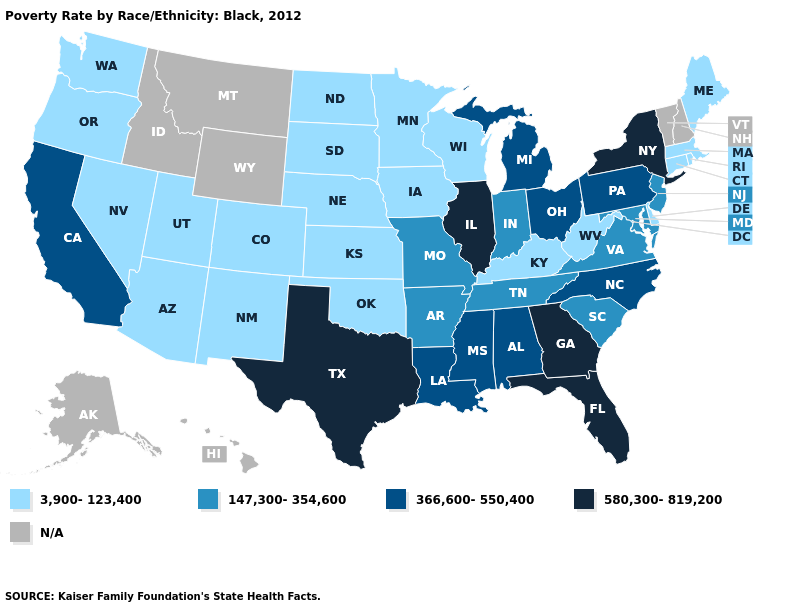Does Delaware have the highest value in the USA?
Give a very brief answer. No. Does Connecticut have the lowest value in the USA?
Keep it brief. Yes. Does the first symbol in the legend represent the smallest category?
Concise answer only. Yes. Name the states that have a value in the range 3,900-123,400?
Answer briefly. Arizona, Colorado, Connecticut, Delaware, Iowa, Kansas, Kentucky, Maine, Massachusetts, Minnesota, Nebraska, Nevada, New Mexico, North Dakota, Oklahoma, Oregon, Rhode Island, South Dakota, Utah, Washington, West Virginia, Wisconsin. What is the value of Hawaii?
Answer briefly. N/A. Name the states that have a value in the range 147,300-354,600?
Answer briefly. Arkansas, Indiana, Maryland, Missouri, New Jersey, South Carolina, Tennessee, Virginia. Which states have the lowest value in the Northeast?
Short answer required. Connecticut, Maine, Massachusetts, Rhode Island. What is the value of Washington?
Concise answer only. 3,900-123,400. Which states have the highest value in the USA?
Quick response, please. Florida, Georgia, Illinois, New York, Texas. Name the states that have a value in the range N/A?
Answer briefly. Alaska, Hawaii, Idaho, Montana, New Hampshire, Vermont, Wyoming. Does the map have missing data?
Keep it brief. Yes. What is the value of Maryland?
Give a very brief answer. 147,300-354,600. 